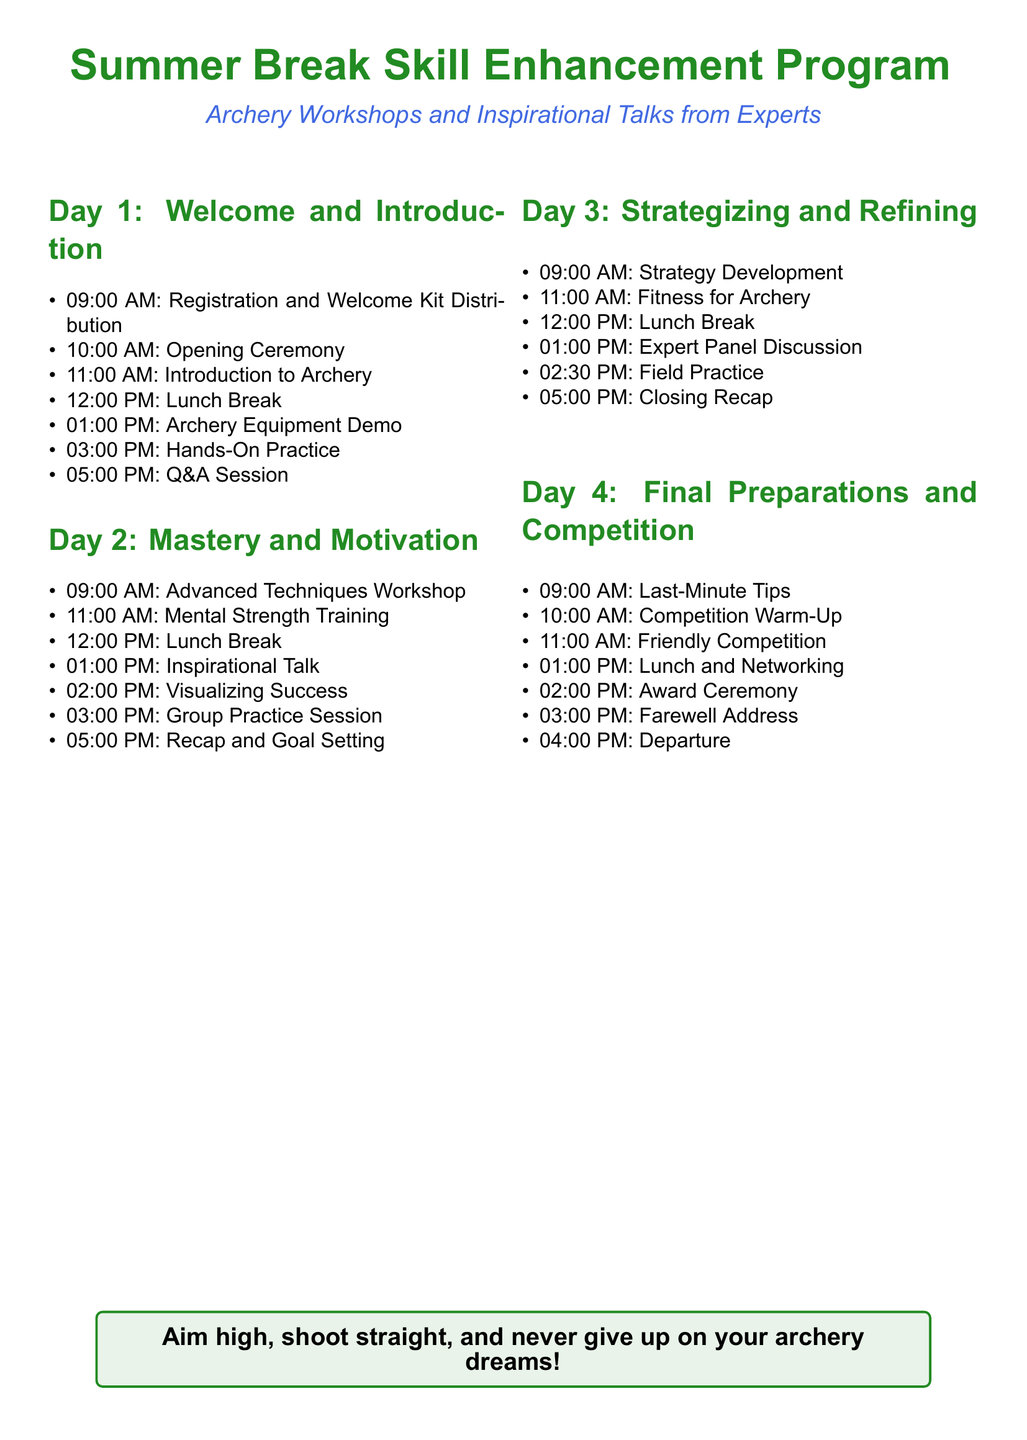What time does registration begin? Registration starts at 9:00 AM on Day 1.
Answer: 09:00 AM How many days is the program? The document outlines a four-day itinerary for the program.
Answer: 4 What is one of the activities scheduled for Day 2? The itinerary specifies an “Inspirational Talk” at 1:00 PM on Day 2.
Answer: Inspirational Talk What should participants do at 3:00 PM on Day 3? Participants are scheduled for a “Field Practice” session at that time.
Answer: Field Practice What is the primary theme of the program? The program combines archery workshops with motivational sessions by experts.
Answer: Archery Workshops and Inspirational Talks What is scheduled after the lunch break on Day 4? After the lunch break, there is a “Networking” session planned.
Answer: Networking What is one aspect covered during the Day 2 workshop? Participants will focus on “Mental Strength Training” during Day 2.
Answer: Mental Strength Training What is the activity at 10:00 AM on Day 4? The schedule indicates a “Competition Warm-Up” at that time.
Answer: Competition Warm-Up What is the message in the tcolorbox at the bottom of the document? The message encourages aiming high and persevering in archery dreams.
Answer: Aim high, shoot straight, and never give up on your archery dreams! 